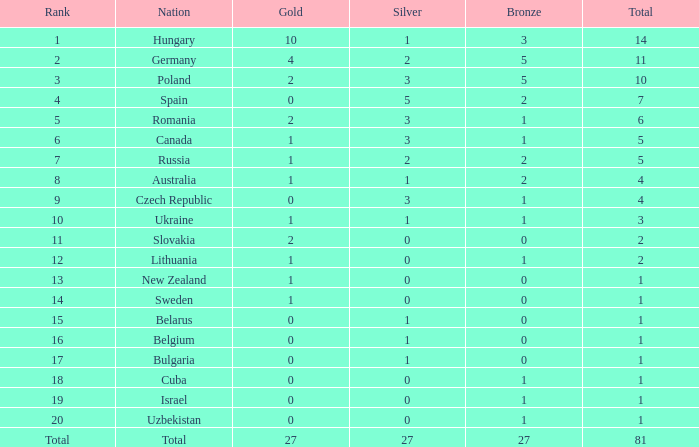What amount of bronze medals include a gold bigger than 1, a silver under 3, associated with germany, and a total surpassing 11? 0.0. 